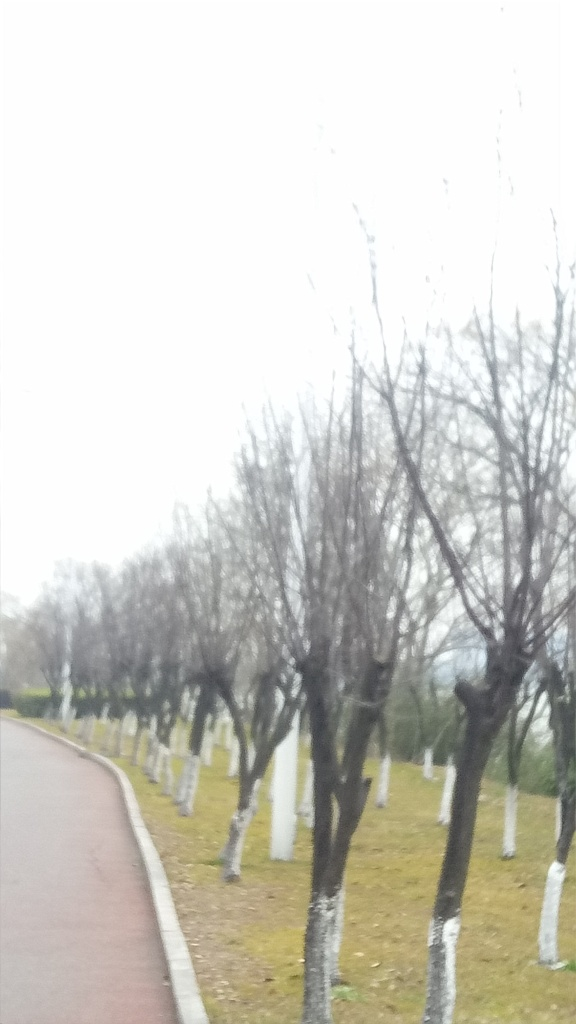Does the image suffer from color distortion? No, the image does not appear to suffer from color distortion. The colors seem natural and consistent with a typical overcast day, where lighting may look flat, leading to less vibrant colors. The white-painted bases of the trees, the green grass, and the gray sky are all represented in a manner that aligns with typical color perception under such weather conditions. 